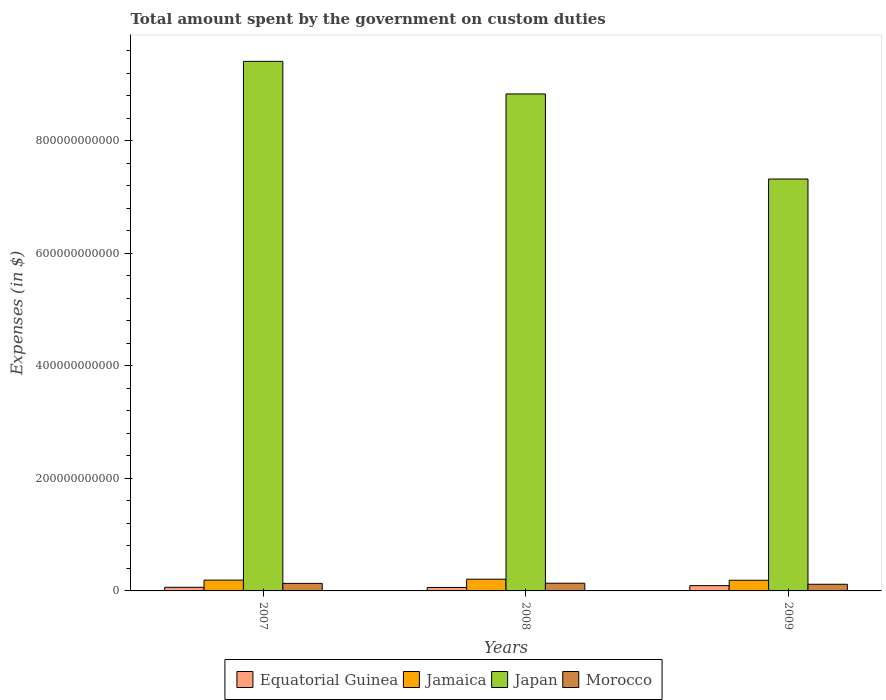How many different coloured bars are there?
Offer a very short reply. 4. Are the number of bars per tick equal to the number of legend labels?
Ensure brevity in your answer.  Yes. Are the number of bars on each tick of the X-axis equal?
Offer a very short reply. Yes. How many bars are there on the 3rd tick from the right?
Offer a terse response. 4. What is the amount spent on custom duties by the government in Japan in 2009?
Ensure brevity in your answer.  7.32e+11. Across all years, what is the maximum amount spent on custom duties by the government in Equatorial Guinea?
Make the answer very short. 9.40e+09. Across all years, what is the minimum amount spent on custom duties by the government in Equatorial Guinea?
Your response must be concise. 6.14e+09. What is the total amount spent on custom duties by the government in Equatorial Guinea in the graph?
Provide a succinct answer. 2.20e+1. What is the difference between the amount spent on custom duties by the government in Equatorial Guinea in 2007 and that in 2009?
Offer a very short reply. -2.94e+09. What is the difference between the amount spent on custom duties by the government in Japan in 2007 and the amount spent on custom duties by the government in Equatorial Guinea in 2009?
Your answer should be compact. 9.32e+11. What is the average amount spent on custom duties by the government in Equatorial Guinea per year?
Offer a very short reply. 7.34e+09. In the year 2008, what is the difference between the amount spent on custom duties by the government in Equatorial Guinea and amount spent on custom duties by the government in Japan?
Your answer should be very brief. -8.77e+11. What is the ratio of the amount spent on custom duties by the government in Japan in 2007 to that in 2008?
Keep it short and to the point. 1.07. Is the amount spent on custom duties by the government in Equatorial Guinea in 2007 less than that in 2009?
Provide a succinct answer. Yes. Is the difference between the amount spent on custom duties by the government in Equatorial Guinea in 2007 and 2008 greater than the difference between the amount spent on custom duties by the government in Japan in 2007 and 2008?
Your answer should be compact. No. What is the difference between the highest and the second highest amount spent on custom duties by the government in Jamaica?
Keep it short and to the point. 1.62e+09. What is the difference between the highest and the lowest amount spent on custom duties by the government in Morocco?
Offer a terse response. 1.88e+09. What does the 1st bar from the left in 2007 represents?
Your answer should be compact. Equatorial Guinea. What does the 3rd bar from the right in 2009 represents?
Your response must be concise. Jamaica. How many bars are there?
Keep it short and to the point. 12. Are all the bars in the graph horizontal?
Your response must be concise. No. What is the difference between two consecutive major ticks on the Y-axis?
Offer a terse response. 2.00e+11. Does the graph contain grids?
Ensure brevity in your answer.  No. Where does the legend appear in the graph?
Keep it short and to the point. Bottom center. How many legend labels are there?
Offer a terse response. 4. How are the legend labels stacked?
Offer a terse response. Horizontal. What is the title of the graph?
Provide a short and direct response. Total amount spent by the government on custom duties. Does "Mauritania" appear as one of the legend labels in the graph?
Your response must be concise. No. What is the label or title of the X-axis?
Offer a terse response. Years. What is the label or title of the Y-axis?
Offer a very short reply. Expenses (in $). What is the Expenses (in $) of Equatorial Guinea in 2007?
Your answer should be compact. 6.46e+09. What is the Expenses (in $) of Jamaica in 2007?
Give a very brief answer. 1.92e+1. What is the Expenses (in $) of Japan in 2007?
Make the answer very short. 9.41e+11. What is the Expenses (in $) in Morocco in 2007?
Your answer should be very brief. 1.34e+1. What is the Expenses (in $) of Equatorial Guinea in 2008?
Your response must be concise. 6.14e+09. What is the Expenses (in $) in Jamaica in 2008?
Give a very brief answer. 2.08e+1. What is the Expenses (in $) of Japan in 2008?
Your answer should be compact. 8.83e+11. What is the Expenses (in $) in Morocco in 2008?
Make the answer very short. 1.37e+1. What is the Expenses (in $) of Equatorial Guinea in 2009?
Your answer should be compact. 9.40e+09. What is the Expenses (in $) in Jamaica in 2009?
Make the answer very short. 1.89e+1. What is the Expenses (in $) in Japan in 2009?
Offer a very short reply. 7.32e+11. What is the Expenses (in $) in Morocco in 2009?
Provide a short and direct response. 1.18e+1. Across all years, what is the maximum Expenses (in $) of Equatorial Guinea?
Give a very brief answer. 9.40e+09. Across all years, what is the maximum Expenses (in $) of Jamaica?
Offer a terse response. 2.08e+1. Across all years, what is the maximum Expenses (in $) in Japan?
Offer a very short reply. 9.41e+11. Across all years, what is the maximum Expenses (in $) of Morocco?
Offer a terse response. 1.37e+1. Across all years, what is the minimum Expenses (in $) of Equatorial Guinea?
Offer a very short reply. 6.14e+09. Across all years, what is the minimum Expenses (in $) in Jamaica?
Give a very brief answer. 1.89e+1. Across all years, what is the minimum Expenses (in $) in Japan?
Offer a very short reply. 7.32e+11. Across all years, what is the minimum Expenses (in $) in Morocco?
Provide a short and direct response. 1.18e+1. What is the total Expenses (in $) of Equatorial Guinea in the graph?
Ensure brevity in your answer.  2.20e+1. What is the total Expenses (in $) in Jamaica in the graph?
Provide a succinct answer. 5.90e+1. What is the total Expenses (in $) in Japan in the graph?
Your response must be concise. 2.56e+12. What is the total Expenses (in $) in Morocco in the graph?
Make the answer very short. 3.90e+1. What is the difference between the Expenses (in $) in Equatorial Guinea in 2007 and that in 2008?
Offer a very short reply. 3.15e+08. What is the difference between the Expenses (in $) in Jamaica in 2007 and that in 2008?
Give a very brief answer. -1.62e+09. What is the difference between the Expenses (in $) of Japan in 2007 and that in 2008?
Offer a terse response. 5.79e+1. What is the difference between the Expenses (in $) of Morocco in 2007 and that in 2008?
Provide a short and direct response. -2.91e+08. What is the difference between the Expenses (in $) in Equatorial Guinea in 2007 and that in 2009?
Make the answer very short. -2.94e+09. What is the difference between the Expenses (in $) in Jamaica in 2007 and that in 2009?
Offer a terse response. 2.75e+08. What is the difference between the Expenses (in $) in Japan in 2007 and that in 2009?
Your response must be concise. 2.09e+11. What is the difference between the Expenses (in $) of Morocco in 2007 and that in 2009?
Make the answer very short. 1.59e+09. What is the difference between the Expenses (in $) in Equatorial Guinea in 2008 and that in 2009?
Give a very brief answer. -3.26e+09. What is the difference between the Expenses (in $) of Jamaica in 2008 and that in 2009?
Give a very brief answer. 1.89e+09. What is the difference between the Expenses (in $) in Japan in 2008 and that in 2009?
Your response must be concise. 1.51e+11. What is the difference between the Expenses (in $) in Morocco in 2008 and that in 2009?
Make the answer very short. 1.88e+09. What is the difference between the Expenses (in $) in Equatorial Guinea in 2007 and the Expenses (in $) in Jamaica in 2008?
Offer a very short reply. -1.44e+1. What is the difference between the Expenses (in $) in Equatorial Guinea in 2007 and the Expenses (in $) in Japan in 2008?
Offer a very short reply. -8.77e+11. What is the difference between the Expenses (in $) of Equatorial Guinea in 2007 and the Expenses (in $) of Morocco in 2008?
Your answer should be very brief. -7.25e+09. What is the difference between the Expenses (in $) of Jamaica in 2007 and the Expenses (in $) of Japan in 2008?
Your response must be concise. -8.64e+11. What is the difference between the Expenses (in $) of Jamaica in 2007 and the Expenses (in $) of Morocco in 2008?
Give a very brief answer. 5.50e+09. What is the difference between the Expenses (in $) of Japan in 2007 and the Expenses (in $) of Morocco in 2008?
Offer a terse response. 9.27e+11. What is the difference between the Expenses (in $) of Equatorial Guinea in 2007 and the Expenses (in $) of Jamaica in 2009?
Your answer should be compact. -1.25e+1. What is the difference between the Expenses (in $) in Equatorial Guinea in 2007 and the Expenses (in $) in Japan in 2009?
Keep it short and to the point. -7.25e+11. What is the difference between the Expenses (in $) in Equatorial Guinea in 2007 and the Expenses (in $) in Morocco in 2009?
Offer a terse response. -5.37e+09. What is the difference between the Expenses (in $) of Jamaica in 2007 and the Expenses (in $) of Japan in 2009?
Provide a short and direct response. -7.13e+11. What is the difference between the Expenses (in $) in Jamaica in 2007 and the Expenses (in $) in Morocco in 2009?
Your response must be concise. 7.38e+09. What is the difference between the Expenses (in $) of Japan in 2007 and the Expenses (in $) of Morocco in 2009?
Make the answer very short. 9.29e+11. What is the difference between the Expenses (in $) of Equatorial Guinea in 2008 and the Expenses (in $) of Jamaica in 2009?
Make the answer very short. -1.28e+1. What is the difference between the Expenses (in $) in Equatorial Guinea in 2008 and the Expenses (in $) in Japan in 2009?
Make the answer very short. -7.26e+11. What is the difference between the Expenses (in $) in Equatorial Guinea in 2008 and the Expenses (in $) in Morocco in 2009?
Your answer should be compact. -5.68e+09. What is the difference between the Expenses (in $) of Jamaica in 2008 and the Expenses (in $) of Japan in 2009?
Offer a very short reply. -7.11e+11. What is the difference between the Expenses (in $) in Jamaica in 2008 and the Expenses (in $) in Morocco in 2009?
Ensure brevity in your answer.  8.99e+09. What is the difference between the Expenses (in $) of Japan in 2008 and the Expenses (in $) of Morocco in 2009?
Offer a terse response. 8.71e+11. What is the average Expenses (in $) of Equatorial Guinea per year?
Provide a short and direct response. 7.34e+09. What is the average Expenses (in $) in Jamaica per year?
Make the answer very short. 1.97e+1. What is the average Expenses (in $) of Japan per year?
Your response must be concise. 8.52e+11. What is the average Expenses (in $) in Morocco per year?
Provide a short and direct response. 1.30e+1. In the year 2007, what is the difference between the Expenses (in $) of Equatorial Guinea and Expenses (in $) of Jamaica?
Your answer should be compact. -1.27e+1. In the year 2007, what is the difference between the Expenses (in $) in Equatorial Guinea and Expenses (in $) in Japan?
Provide a succinct answer. -9.35e+11. In the year 2007, what is the difference between the Expenses (in $) of Equatorial Guinea and Expenses (in $) of Morocco?
Your response must be concise. -6.96e+09. In the year 2007, what is the difference between the Expenses (in $) in Jamaica and Expenses (in $) in Japan?
Provide a short and direct response. -9.22e+11. In the year 2007, what is the difference between the Expenses (in $) of Jamaica and Expenses (in $) of Morocco?
Make the answer very short. 5.79e+09. In the year 2007, what is the difference between the Expenses (in $) of Japan and Expenses (in $) of Morocco?
Provide a succinct answer. 9.28e+11. In the year 2008, what is the difference between the Expenses (in $) of Equatorial Guinea and Expenses (in $) of Jamaica?
Make the answer very short. -1.47e+1. In the year 2008, what is the difference between the Expenses (in $) of Equatorial Guinea and Expenses (in $) of Japan?
Provide a short and direct response. -8.77e+11. In the year 2008, what is the difference between the Expenses (in $) in Equatorial Guinea and Expenses (in $) in Morocco?
Provide a succinct answer. -7.56e+09. In the year 2008, what is the difference between the Expenses (in $) of Jamaica and Expenses (in $) of Japan?
Your answer should be compact. -8.62e+11. In the year 2008, what is the difference between the Expenses (in $) of Jamaica and Expenses (in $) of Morocco?
Provide a succinct answer. 7.12e+09. In the year 2008, what is the difference between the Expenses (in $) in Japan and Expenses (in $) in Morocco?
Your answer should be compact. 8.69e+11. In the year 2009, what is the difference between the Expenses (in $) of Equatorial Guinea and Expenses (in $) of Jamaica?
Make the answer very short. -9.53e+09. In the year 2009, what is the difference between the Expenses (in $) of Equatorial Guinea and Expenses (in $) of Japan?
Ensure brevity in your answer.  -7.22e+11. In the year 2009, what is the difference between the Expenses (in $) of Equatorial Guinea and Expenses (in $) of Morocco?
Make the answer very short. -2.43e+09. In the year 2009, what is the difference between the Expenses (in $) in Jamaica and Expenses (in $) in Japan?
Your answer should be compact. -7.13e+11. In the year 2009, what is the difference between the Expenses (in $) of Jamaica and Expenses (in $) of Morocco?
Your response must be concise. 7.10e+09. In the year 2009, what is the difference between the Expenses (in $) in Japan and Expenses (in $) in Morocco?
Ensure brevity in your answer.  7.20e+11. What is the ratio of the Expenses (in $) of Equatorial Guinea in 2007 to that in 2008?
Provide a succinct answer. 1.05. What is the ratio of the Expenses (in $) in Jamaica in 2007 to that in 2008?
Your response must be concise. 0.92. What is the ratio of the Expenses (in $) in Japan in 2007 to that in 2008?
Offer a terse response. 1.07. What is the ratio of the Expenses (in $) of Morocco in 2007 to that in 2008?
Offer a very short reply. 0.98. What is the ratio of the Expenses (in $) in Equatorial Guinea in 2007 to that in 2009?
Offer a very short reply. 0.69. What is the ratio of the Expenses (in $) in Jamaica in 2007 to that in 2009?
Your response must be concise. 1.01. What is the ratio of the Expenses (in $) in Morocco in 2007 to that in 2009?
Provide a succinct answer. 1.13. What is the ratio of the Expenses (in $) of Equatorial Guinea in 2008 to that in 2009?
Keep it short and to the point. 0.65. What is the ratio of the Expenses (in $) in Jamaica in 2008 to that in 2009?
Your answer should be compact. 1.1. What is the ratio of the Expenses (in $) of Japan in 2008 to that in 2009?
Keep it short and to the point. 1.21. What is the ratio of the Expenses (in $) in Morocco in 2008 to that in 2009?
Make the answer very short. 1.16. What is the difference between the highest and the second highest Expenses (in $) of Equatorial Guinea?
Make the answer very short. 2.94e+09. What is the difference between the highest and the second highest Expenses (in $) in Jamaica?
Make the answer very short. 1.62e+09. What is the difference between the highest and the second highest Expenses (in $) of Japan?
Offer a very short reply. 5.79e+1. What is the difference between the highest and the second highest Expenses (in $) of Morocco?
Provide a succinct answer. 2.91e+08. What is the difference between the highest and the lowest Expenses (in $) of Equatorial Guinea?
Keep it short and to the point. 3.26e+09. What is the difference between the highest and the lowest Expenses (in $) of Jamaica?
Your answer should be very brief. 1.89e+09. What is the difference between the highest and the lowest Expenses (in $) in Japan?
Provide a short and direct response. 2.09e+11. What is the difference between the highest and the lowest Expenses (in $) in Morocco?
Keep it short and to the point. 1.88e+09. 